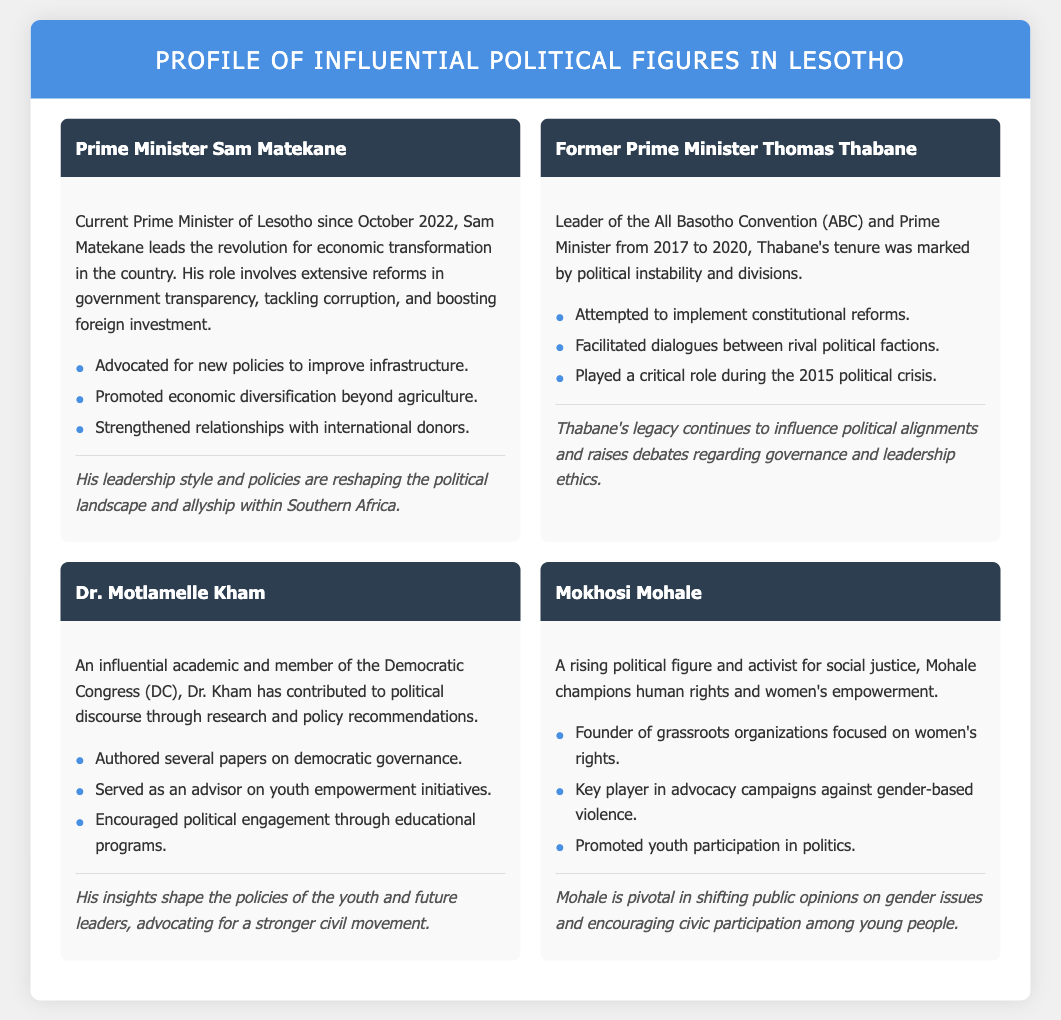What is the current position of Sam Matekane? Sam Matekane is currently the Prime Minister of Lesotho, a role he has held since October 2022.
Answer: Prime Minister Which political party does Thomas Thabane lead? Thomas Thabane is the leader of the All Basotho Convention (ABC).
Answer: All Basotho Convention What years did Thabane serve as Prime Minister? Thabane served as Prime Minister from 2017 to 2020.
Answer: 2017 to 2020 What major focus does Dr. Motlamelle Kham have in his advocacy? Dr. Kham focuses on democratic governance and youth empowerment initiatives.
Answer: Youth empowerment Who is known for being an activist for social justice? Mokhosi Mohale is recognized as a rising political figure and activist for social justice.
Answer: Mokhosi Mohale What significant issue does Mokhosi Mohale advocate against? Mohale is a key player in advocacy campaigns against gender-based violence.
Answer: Gender-based violence What is one of Sam Matekane's contributions to Lesotho's government? Sam Matekane has advocated for new policies to improve infrastructure.
Answer: New policies for infrastructure How does Dr. Motlamelle Kham contribute to politics? Dr. Kham contributes through research and policy recommendations, specifically on governance.
Answer: Research and policy recommendations What leadership style is said to influence the political landscape in Southern Africa? Sam Matekane's leadership style and policies are influencing the political landscape.
Answer: Sam Matekane's leadership style 